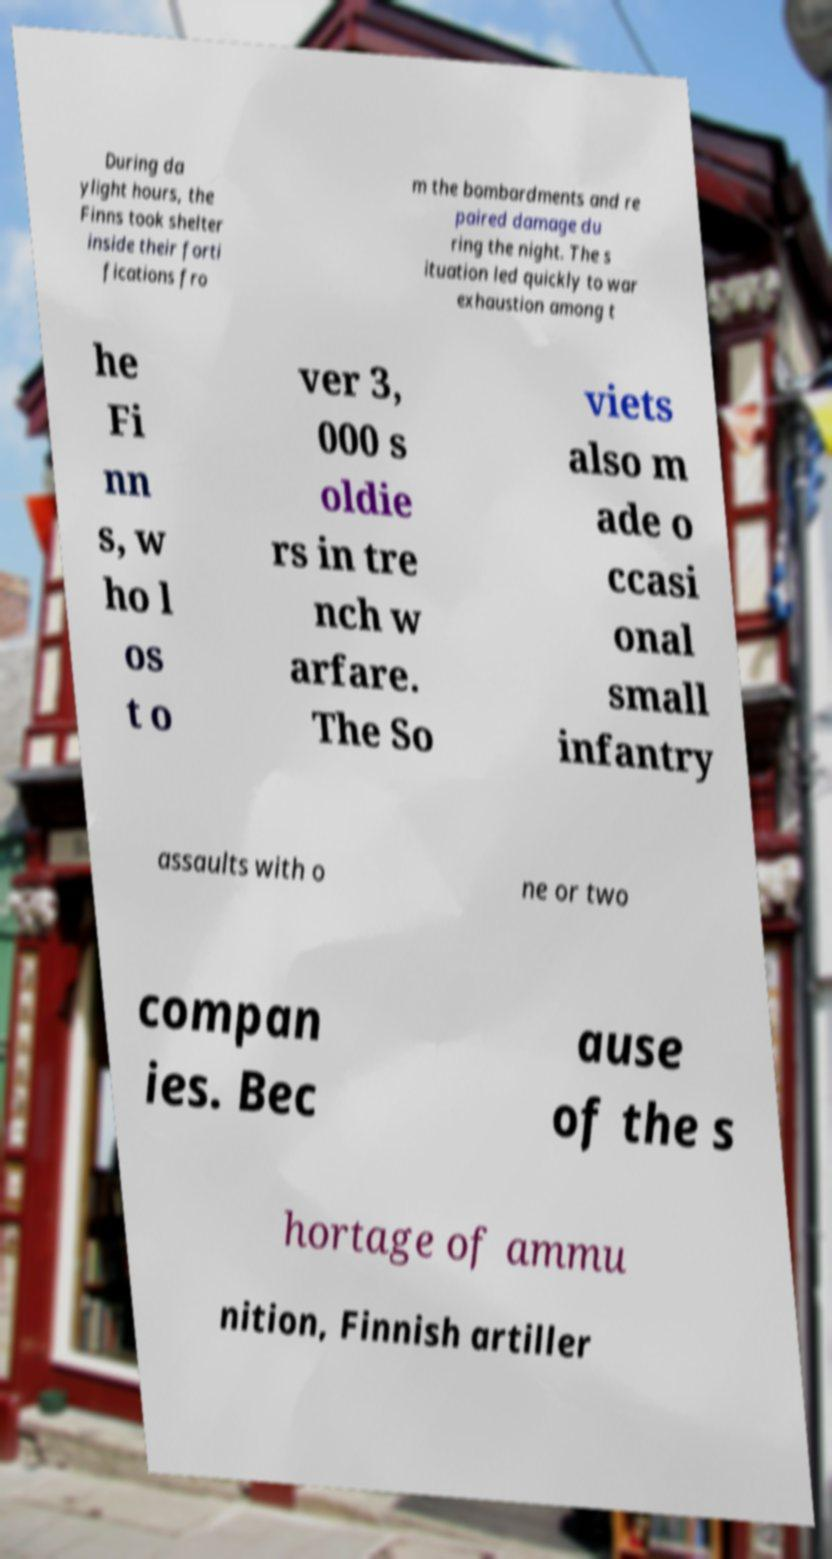For documentation purposes, I need the text within this image transcribed. Could you provide that? During da ylight hours, the Finns took shelter inside their forti fications fro m the bombardments and re paired damage du ring the night. The s ituation led quickly to war exhaustion among t he Fi nn s, w ho l os t o ver 3, 000 s oldie rs in tre nch w arfare. The So viets also m ade o ccasi onal small infantry assaults with o ne or two compan ies. Bec ause of the s hortage of ammu nition, Finnish artiller 